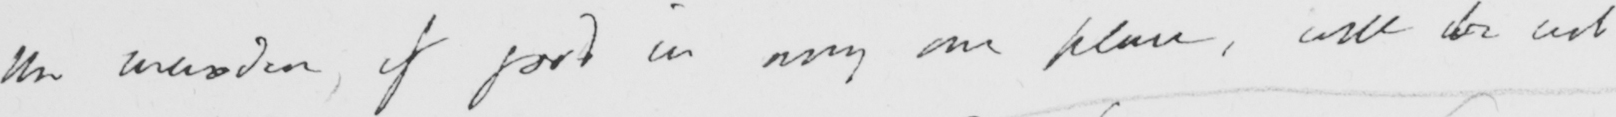What is written in this line of handwriting? the wisdom , if good in any one place , will be act 